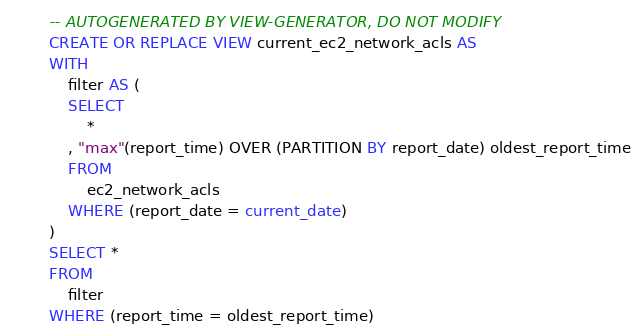Convert code to text. <code><loc_0><loc_0><loc_500><loc_500><_SQL_>
-- AUTOGENERATED BY VIEW-GENERATOR, DO NOT MODIFY
CREATE OR REPLACE VIEW current_ec2_network_acls AS 
WITH
	filter AS (
	SELECT
		*
	, "max"(report_time) OVER (PARTITION BY report_date) oldest_report_time
	FROM
		ec2_network_acls
	WHERE (report_date = current_date)
) 
SELECT *
FROM
	filter
WHERE (report_time = oldest_report_time)</code> 